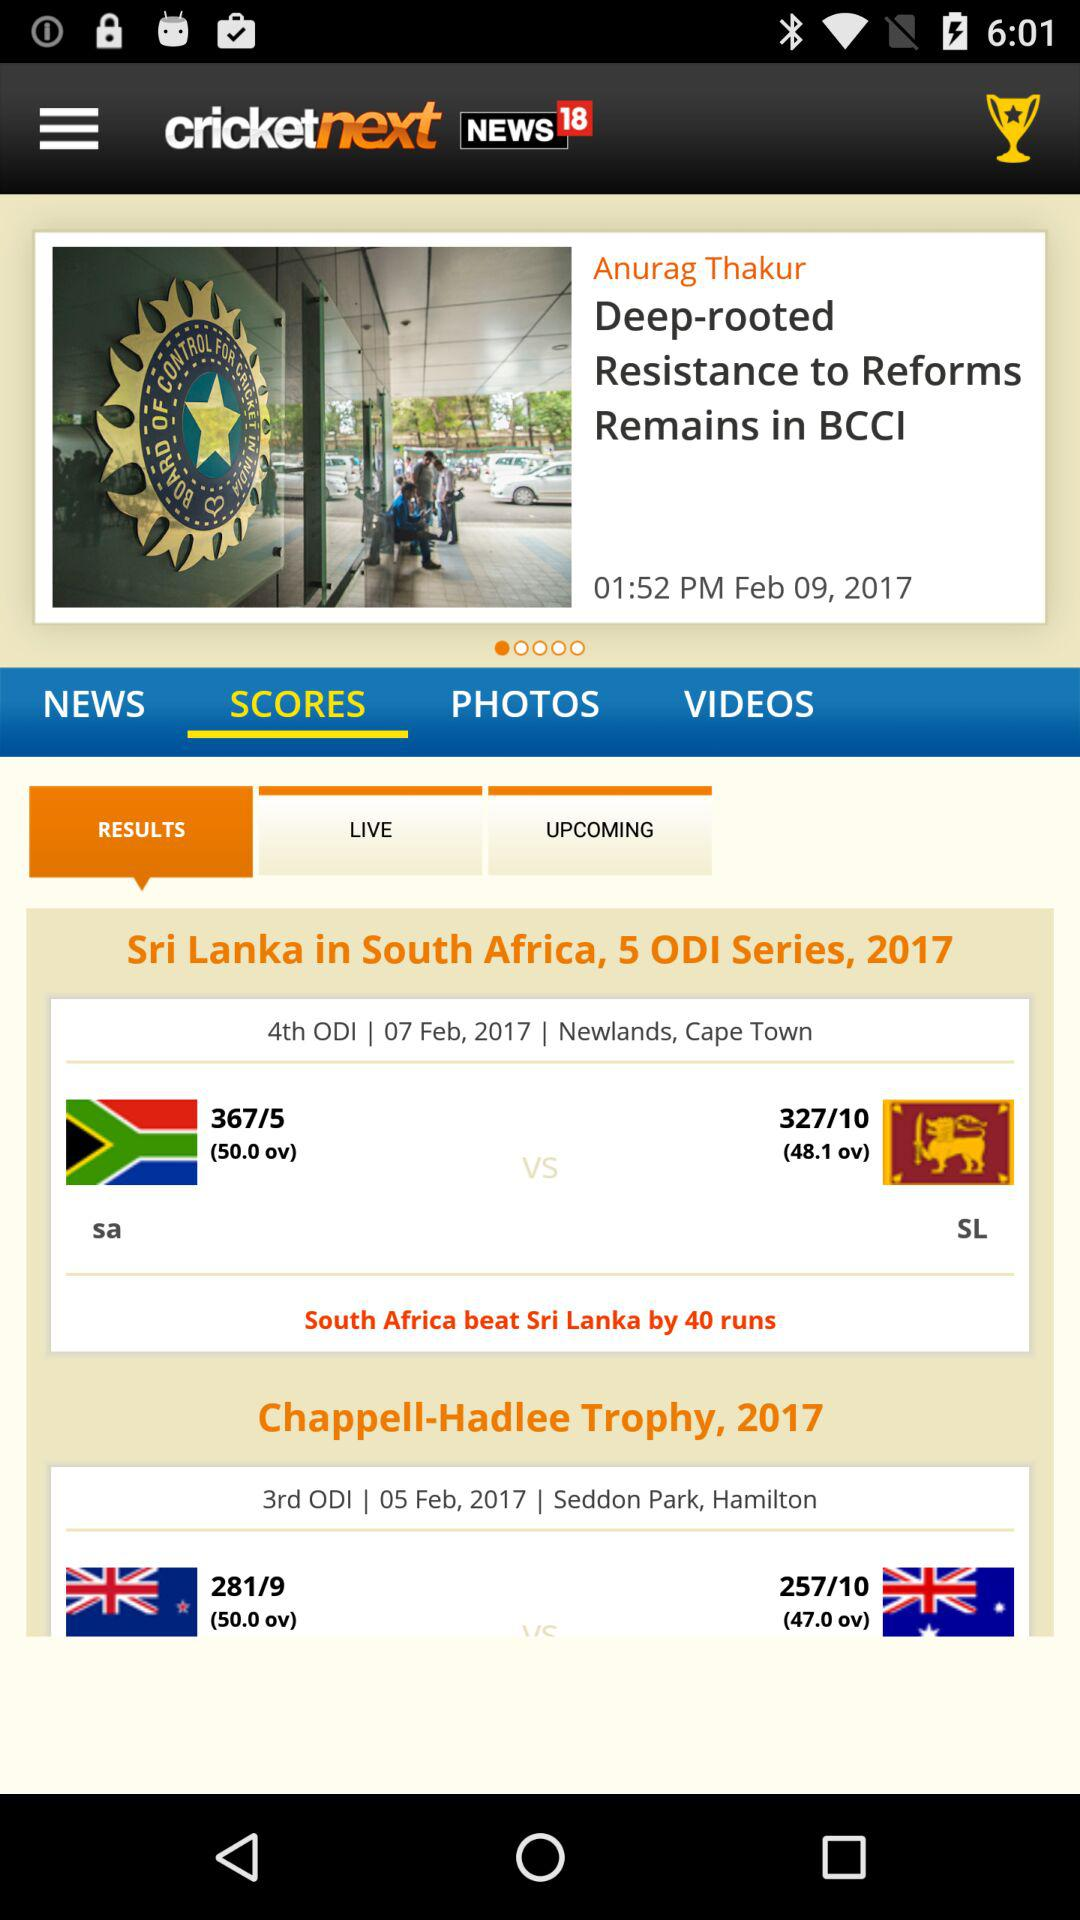What are the runs scored by "Sri Lanka" in the 4th ODI match? The runs scored by "Sri Lanka" in the 4th ODI match are 327. 